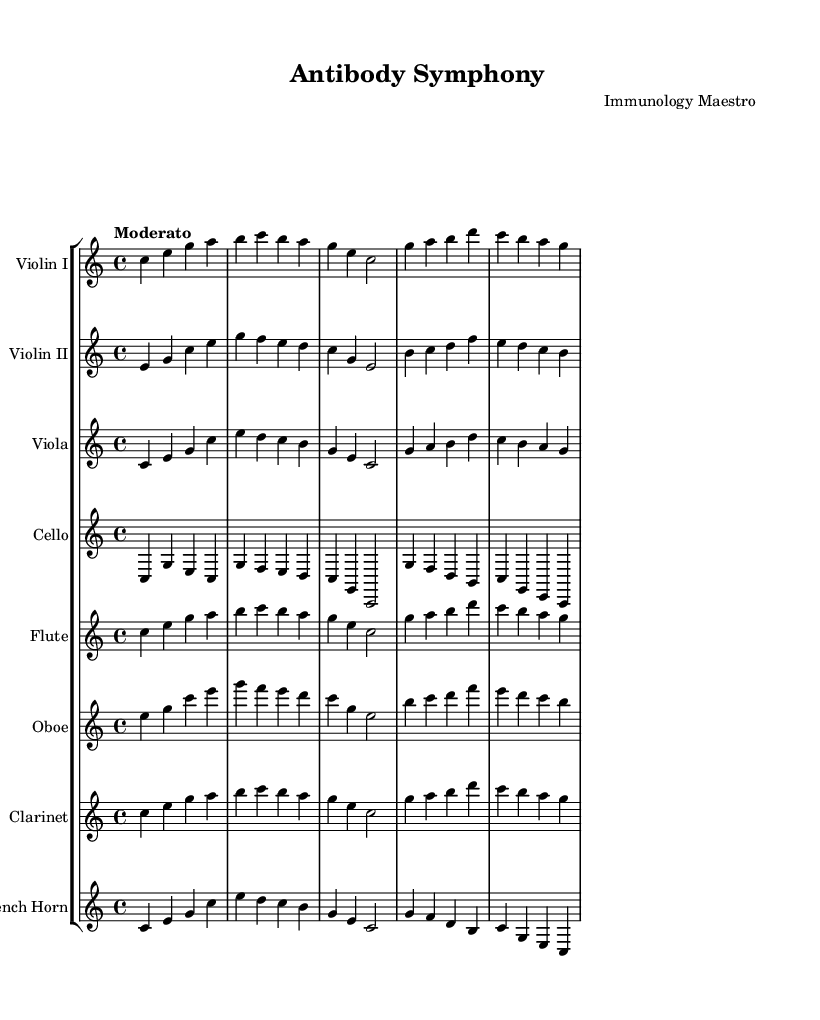What is the key signature of this music? The key signature is C major, which has no sharps or flats.
Answer: C major What is the time signature of this piece? The time signature is identified as 4/4, meaning there are four beats in a measure.
Answer: 4/4 What is the tempo marking of this composition? The tempo marking indicates "Moderato," which refers to a moderate speed.
Answer: Moderato How many instruments are represented in this score? To determine the number of instruments, we count the distinct staves presented: Violin I, Violin II, Viola, Cello, Flute, Oboe, Clarinet, and French Horn. That totals eight instruments.
Answer: 8 Which instruments play the same melody in the first measure? In the first measure, both the Violin I and Flute play the same melody, as indicated by the matching notes.
Answer: Violin I and Flute What does the use of the French Horn signify in this composition? The inclusion of the French Horn often signifies a harmonious blend and richness in orchestral sound, complementing the string section while adding depth to the overall texture of the piece.
Answer: Harmonic richness What is the thematic relationship between the composition and scientific discoveries? The composition is titled "Antibody Symphony," suggesting an inspiration derived from immunological discoveries, likely reflecting the structure and dynamics of antibody response.
Answer: Inspired by immunology 